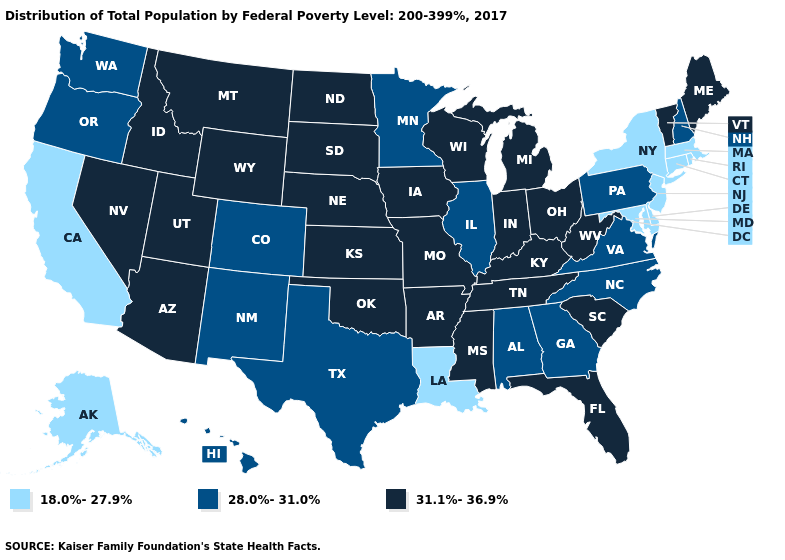Does the map have missing data?
Concise answer only. No. What is the value of Indiana?
Quick response, please. 31.1%-36.9%. What is the highest value in states that border Arkansas?
Give a very brief answer. 31.1%-36.9%. Name the states that have a value in the range 31.1%-36.9%?
Concise answer only. Arizona, Arkansas, Florida, Idaho, Indiana, Iowa, Kansas, Kentucky, Maine, Michigan, Mississippi, Missouri, Montana, Nebraska, Nevada, North Dakota, Ohio, Oklahoma, South Carolina, South Dakota, Tennessee, Utah, Vermont, West Virginia, Wisconsin, Wyoming. Name the states that have a value in the range 31.1%-36.9%?
Short answer required. Arizona, Arkansas, Florida, Idaho, Indiana, Iowa, Kansas, Kentucky, Maine, Michigan, Mississippi, Missouri, Montana, Nebraska, Nevada, North Dakota, Ohio, Oklahoma, South Carolina, South Dakota, Tennessee, Utah, Vermont, West Virginia, Wisconsin, Wyoming. What is the value of Delaware?
Answer briefly. 18.0%-27.9%. Name the states that have a value in the range 28.0%-31.0%?
Give a very brief answer. Alabama, Colorado, Georgia, Hawaii, Illinois, Minnesota, New Hampshire, New Mexico, North Carolina, Oregon, Pennsylvania, Texas, Virginia, Washington. Name the states that have a value in the range 28.0%-31.0%?
Concise answer only. Alabama, Colorado, Georgia, Hawaii, Illinois, Minnesota, New Hampshire, New Mexico, North Carolina, Oregon, Pennsylvania, Texas, Virginia, Washington. Among the states that border Arizona , does Colorado have the lowest value?
Be succinct. No. What is the value of Minnesota?
Short answer required. 28.0%-31.0%. Does the first symbol in the legend represent the smallest category?
Quick response, please. Yes. Does the map have missing data?
Short answer required. No. Does Illinois have the highest value in the MidWest?
Keep it brief. No. 